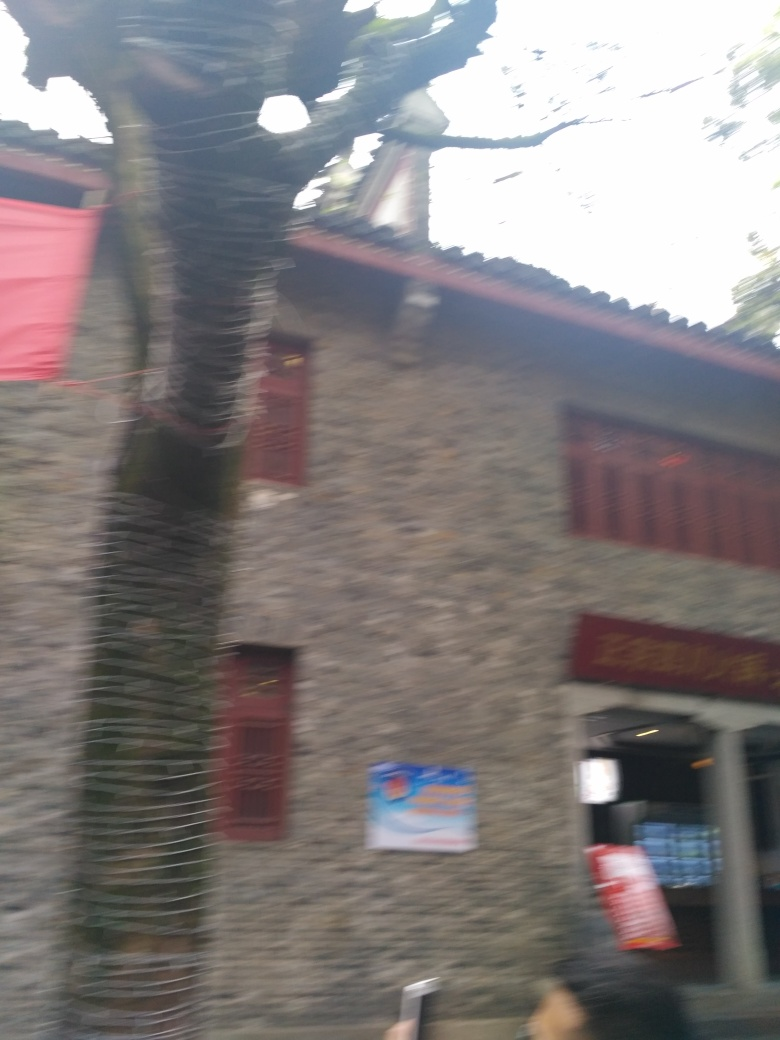Are there any objects or people that stand out in this image? A person is partially visible on the right side of the image, but due to the significant motion blur, no objects or individuals truly stand out with clarity. 